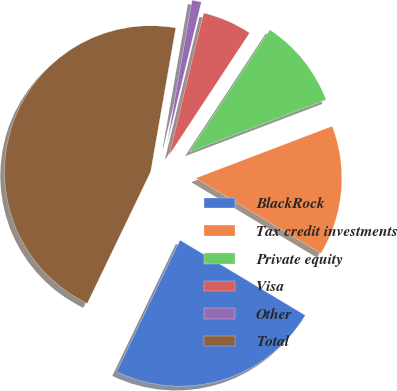<chart> <loc_0><loc_0><loc_500><loc_500><pie_chart><fcel>BlackRock<fcel>Tax credit investments<fcel>Private equity<fcel>Visa<fcel>Other<fcel>Total<nl><fcel>23.54%<fcel>14.4%<fcel>9.94%<fcel>5.49%<fcel>1.03%<fcel>45.61%<nl></chart> 